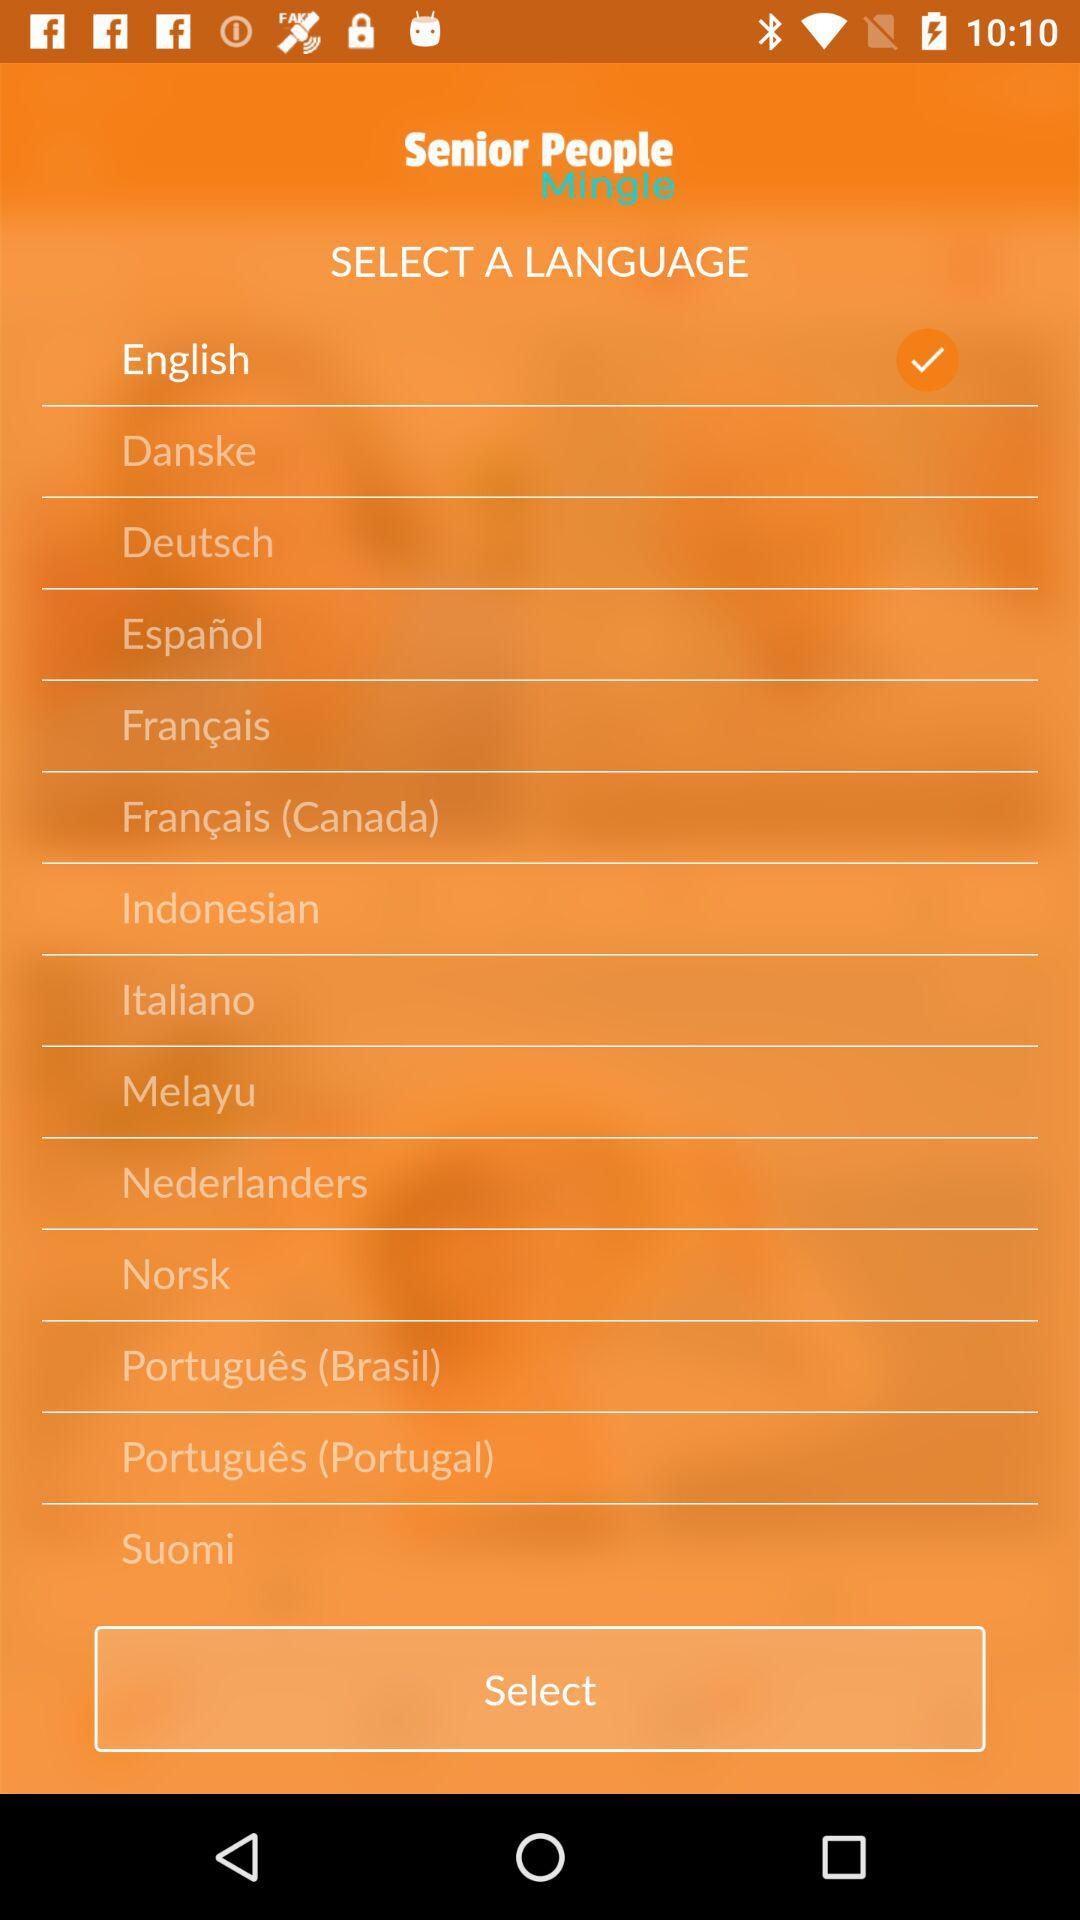Which language is selected? The selected language is English. 